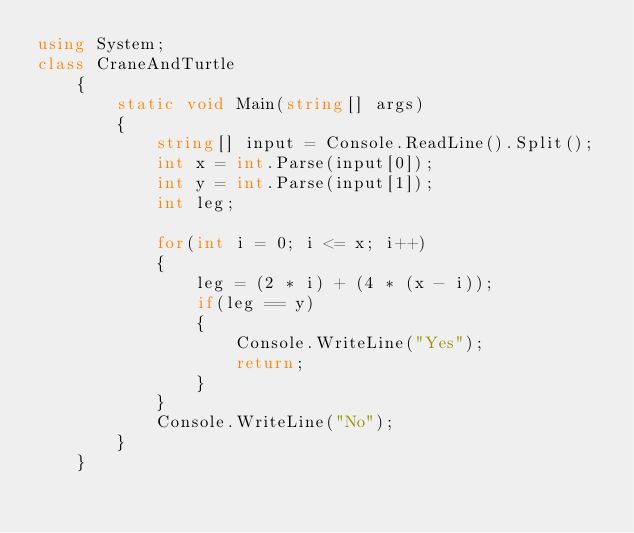Convert code to text. <code><loc_0><loc_0><loc_500><loc_500><_C#_>using System;
class CraneAndTurtle
    {
        static void Main(string[] args)
        {
            string[] input = Console.ReadLine().Split();
            int x = int.Parse(input[0]);
            int y = int.Parse(input[1]);
            int leg;

            for(int i = 0; i <= x; i++)
            {
                leg = (2 * i) + (4 * (x - i));
                if(leg == y)
                {
                    Console.WriteLine("Yes");
                    return;
                }
            }
            Console.WriteLine("No");
        }
    }</code> 